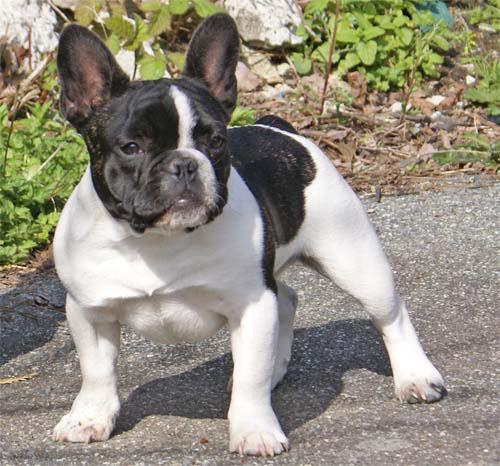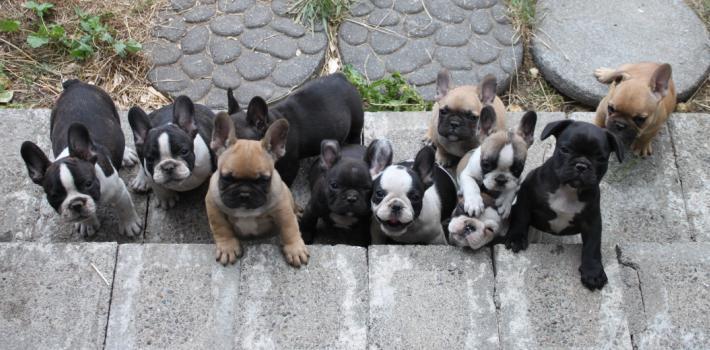The first image is the image on the left, the second image is the image on the right. Assess this claim about the two images: "There are no more than five dogs". Correct or not? Answer yes or no. No. The first image is the image on the left, the second image is the image on the right. Considering the images on both sides, is "An image shows a row of at least 8 dogs on a cement step." valid? Answer yes or no. Yes. 